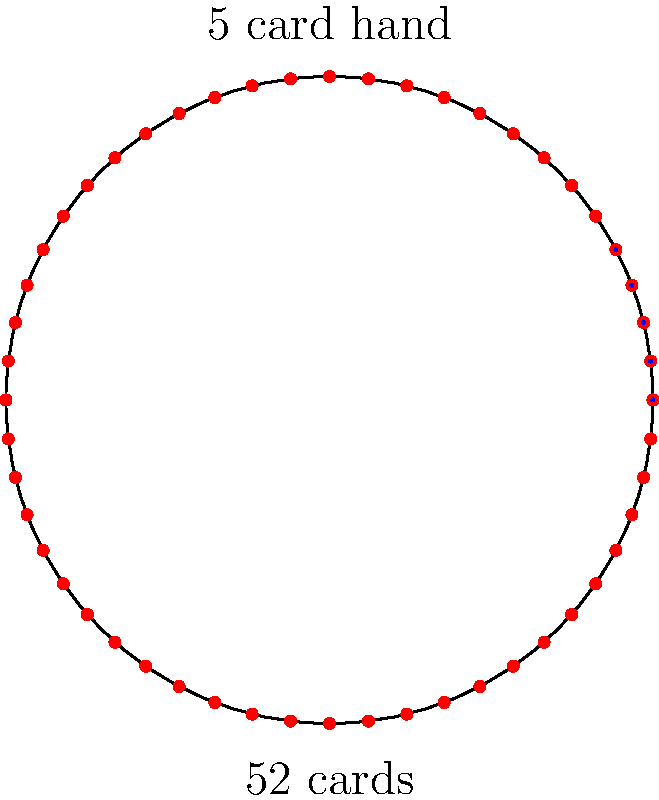In the context of developing a high-stakes online poker website, understanding probability is crucial. Given a standard 52-card deck, what is the probability of drawing a flush (5 cards of the same suit) in a 5-card hand? Express your answer as a fraction in its simplest form. Let's approach this step-by-step:

1) First, we need to calculate the total number of possible 5-card hands. This is given by the combination formula:

   $$\binom{52}{5} = \frac{52!}{5!(52-5)!} = 2,598,960$$

2) Now, we need to calculate the number of possible flush hands:
   
   a) There are 4 suits to choose from.
   b) For each suit, we need to choose 5 cards out of 13.
   
   So, the number of flush hands is:

   $$4 \times \binom{13}{5} = 4 \times \frac{13!}{5!(13-5)!} = 4 \times 1,287 = 5,148$$

3) The probability is then:

   $$P(\text{Flush}) = \frac{\text{Number of favorable outcomes}}{\text{Total number of possible outcomes}} = \frac{5,148}{2,598,960}$$

4) Simplifying this fraction:

   $$\frac{5,148}{2,598,960} = \frac{33}{16,660}$$

This fraction is already in its simplest form.
Answer: $\frac{33}{16,660}$ 